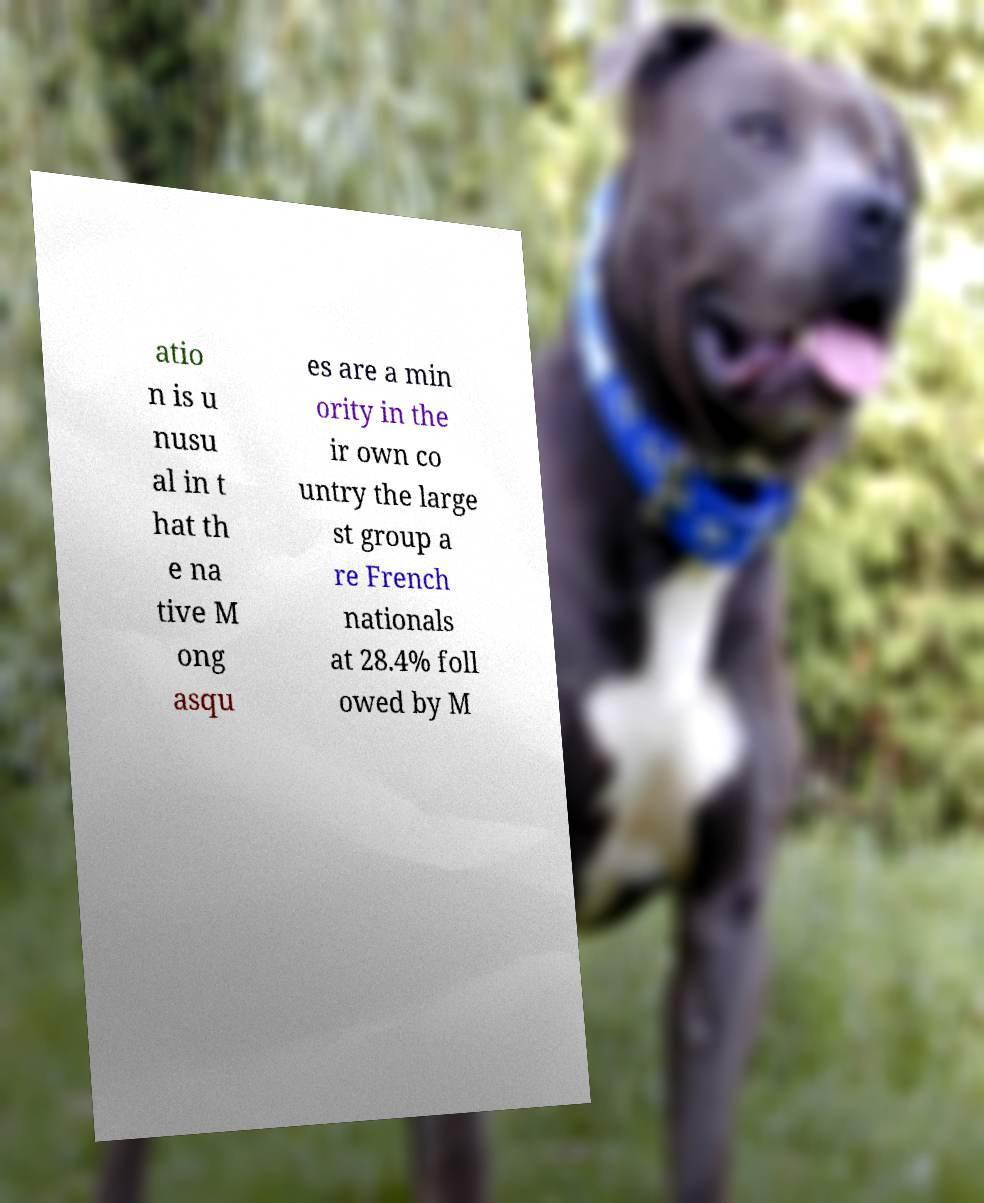Could you assist in decoding the text presented in this image and type it out clearly? atio n is u nusu al in t hat th e na tive M ong asqu es are a min ority in the ir own co untry the large st group a re French nationals at 28.4% foll owed by M 